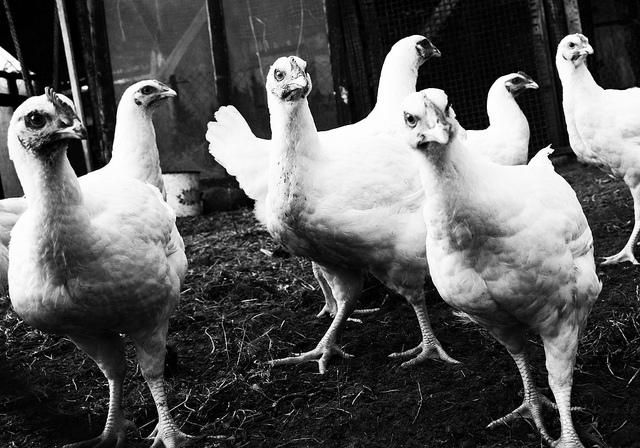What type of animal is in the image? chicken 